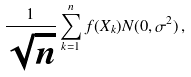Convert formula to latex. <formula><loc_0><loc_0><loc_500><loc_500>\frac { 1 } { \sqrt { n } } \sum _ { k = 1 } ^ { n } f ( X _ { k } ) N ( 0 , \sigma ^ { 2 } ) \, ,</formula> 